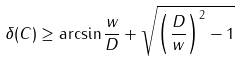Convert formula to latex. <formula><loc_0><loc_0><loc_500><loc_500>\delta ( C ) \geq \arcsin { \frac { w } { D } } + \sqrt { \left ( \frac { D } { w } \right ) ^ { 2 } - 1 }</formula> 